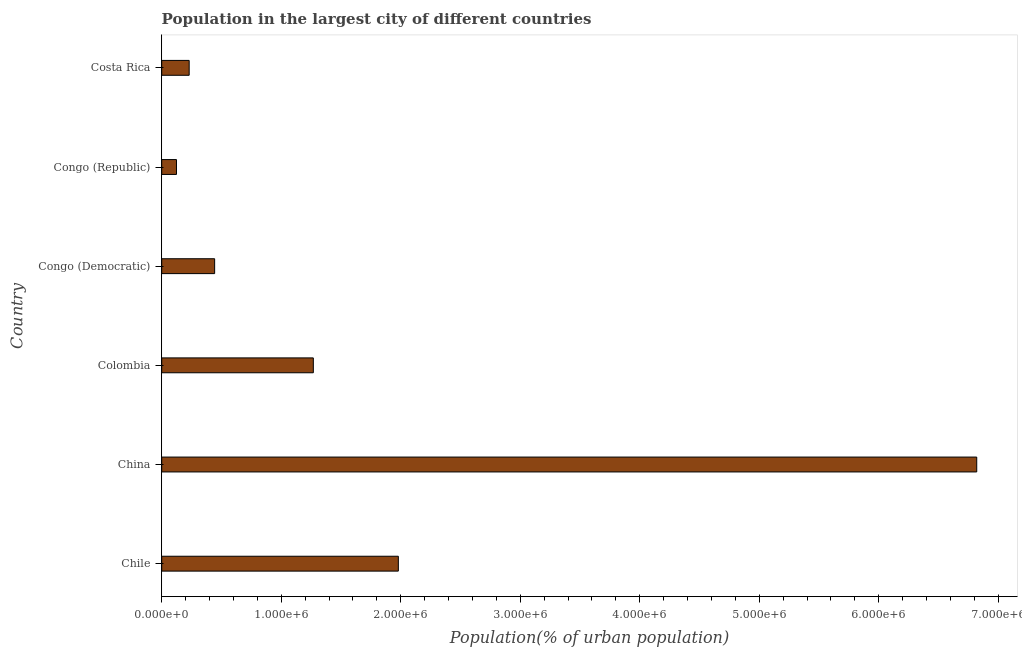What is the title of the graph?
Give a very brief answer. Population in the largest city of different countries. What is the label or title of the X-axis?
Offer a terse response. Population(% of urban population). What is the population in largest city in Chile?
Offer a very short reply. 1.98e+06. Across all countries, what is the maximum population in largest city?
Offer a terse response. 6.82e+06. Across all countries, what is the minimum population in largest city?
Offer a terse response. 1.24e+05. In which country was the population in largest city maximum?
Your answer should be very brief. China. In which country was the population in largest city minimum?
Make the answer very short. Congo (Republic). What is the sum of the population in largest city?
Provide a short and direct response. 1.09e+07. What is the difference between the population in largest city in Chile and Congo (Democratic)?
Your response must be concise. 1.54e+06. What is the average population in largest city per country?
Provide a short and direct response. 1.81e+06. What is the median population in largest city?
Offer a terse response. 8.56e+05. In how many countries, is the population in largest city greater than 1800000 %?
Keep it short and to the point. 2. What is the ratio of the population in largest city in Colombia to that in Congo (Republic)?
Keep it short and to the point. 10.26. What is the difference between the highest and the second highest population in largest city?
Offer a terse response. 4.84e+06. What is the difference between the highest and the lowest population in largest city?
Offer a terse response. 6.70e+06. How many bars are there?
Give a very brief answer. 6. How many countries are there in the graph?
Offer a very short reply. 6. What is the Population(% of urban population) in Chile?
Provide a short and direct response. 1.98e+06. What is the Population(% of urban population) of China?
Make the answer very short. 6.82e+06. What is the Population(% of urban population) in Colombia?
Offer a very short reply. 1.27e+06. What is the Population(% of urban population) of Congo (Democratic)?
Offer a terse response. 4.43e+05. What is the Population(% of urban population) of Congo (Republic)?
Provide a succinct answer. 1.24e+05. What is the Population(% of urban population) of Costa Rica?
Keep it short and to the point. 2.30e+05. What is the difference between the Population(% of urban population) in Chile and China?
Your answer should be compact. -4.84e+06. What is the difference between the Population(% of urban population) in Chile and Colombia?
Your answer should be compact. 7.11e+05. What is the difference between the Population(% of urban population) in Chile and Congo (Democratic)?
Offer a terse response. 1.54e+06. What is the difference between the Population(% of urban population) in Chile and Congo (Republic)?
Provide a succinct answer. 1.86e+06. What is the difference between the Population(% of urban population) in Chile and Costa Rica?
Your response must be concise. 1.75e+06. What is the difference between the Population(% of urban population) in China and Colombia?
Your answer should be compact. 5.55e+06. What is the difference between the Population(% of urban population) in China and Congo (Democratic)?
Ensure brevity in your answer.  6.38e+06. What is the difference between the Population(% of urban population) in China and Congo (Republic)?
Provide a short and direct response. 6.70e+06. What is the difference between the Population(% of urban population) in China and Costa Rica?
Your answer should be compact. 6.59e+06. What is the difference between the Population(% of urban population) in Colombia and Congo (Democratic)?
Offer a very short reply. 8.26e+05. What is the difference between the Population(% of urban population) in Colombia and Congo (Republic)?
Provide a short and direct response. 1.15e+06. What is the difference between the Population(% of urban population) in Colombia and Costa Rica?
Keep it short and to the point. 1.04e+06. What is the difference between the Population(% of urban population) in Congo (Democratic) and Congo (Republic)?
Your response must be concise. 3.19e+05. What is the difference between the Population(% of urban population) in Congo (Democratic) and Costa Rica?
Make the answer very short. 2.13e+05. What is the difference between the Population(% of urban population) in Congo (Republic) and Costa Rica?
Ensure brevity in your answer.  -1.06e+05. What is the ratio of the Population(% of urban population) in Chile to that in China?
Provide a short and direct response. 0.29. What is the ratio of the Population(% of urban population) in Chile to that in Colombia?
Offer a terse response. 1.56. What is the ratio of the Population(% of urban population) in Chile to that in Congo (Democratic)?
Offer a very short reply. 4.47. What is the ratio of the Population(% of urban population) in Chile to that in Congo (Republic)?
Make the answer very short. 16.01. What is the ratio of the Population(% of urban population) in Chile to that in Costa Rica?
Your response must be concise. 8.62. What is the ratio of the Population(% of urban population) in China to that in Colombia?
Ensure brevity in your answer.  5.38. What is the ratio of the Population(% of urban population) in China to that in Congo (Democratic)?
Offer a very short reply. 15.4. What is the ratio of the Population(% of urban population) in China to that in Congo (Republic)?
Offer a terse response. 55.16. What is the ratio of the Population(% of urban population) in China to that in Costa Rica?
Keep it short and to the point. 29.68. What is the ratio of the Population(% of urban population) in Colombia to that in Congo (Democratic)?
Give a very brief answer. 2.87. What is the ratio of the Population(% of urban population) in Colombia to that in Congo (Republic)?
Your response must be concise. 10.26. What is the ratio of the Population(% of urban population) in Colombia to that in Costa Rica?
Provide a succinct answer. 5.52. What is the ratio of the Population(% of urban population) in Congo (Democratic) to that in Congo (Republic)?
Ensure brevity in your answer.  3.58. What is the ratio of the Population(% of urban population) in Congo (Democratic) to that in Costa Rica?
Give a very brief answer. 1.93. What is the ratio of the Population(% of urban population) in Congo (Republic) to that in Costa Rica?
Ensure brevity in your answer.  0.54. 